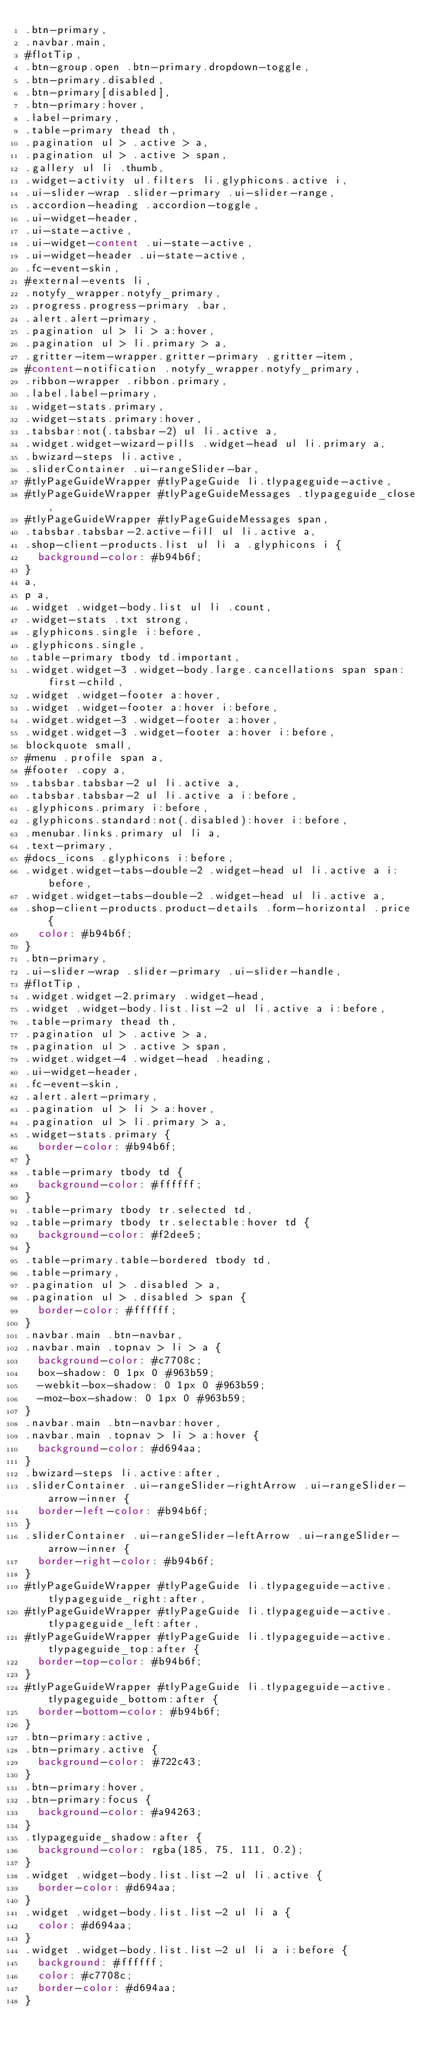<code> <loc_0><loc_0><loc_500><loc_500><_CSS_>.btn-primary,
.navbar.main,
#flotTip,
.btn-group.open .btn-primary.dropdown-toggle,
.btn-primary.disabled,
.btn-primary[disabled],
.btn-primary:hover,
.label-primary,
.table-primary thead th,
.pagination ul > .active > a,
.pagination ul > .active > span,
.gallery ul li .thumb,
.widget-activity ul.filters li.glyphicons.active i,
.ui-slider-wrap .slider-primary .ui-slider-range,
.accordion-heading .accordion-toggle,
.ui-widget-header,
.ui-state-active,
.ui-widget-content .ui-state-active,
.ui-widget-header .ui-state-active,
.fc-event-skin,
#external-events li,
.notyfy_wrapper.notyfy_primary,
.progress.progress-primary .bar,
.alert.alert-primary,
.pagination ul > li > a:hover,
.pagination ul > li.primary > a,
.gritter-item-wrapper.gritter-primary .gritter-item,
#content-notification .notyfy_wrapper.notyfy_primary,
.ribbon-wrapper .ribbon.primary,
.label.label-primary,
.widget-stats.primary,
.widget-stats.primary:hover,
.tabsbar:not(.tabsbar-2) ul li.active a,
.widget.widget-wizard-pills .widget-head ul li.primary a,
.bwizard-steps li.active,
.sliderContainer .ui-rangeSlider-bar,
#tlyPageGuideWrapper #tlyPageGuide li.tlypageguide-active,
#tlyPageGuideWrapper #tlyPageGuideMessages .tlypageguide_close,
#tlyPageGuideWrapper #tlyPageGuideMessages span,
.tabsbar.tabsbar-2.active-fill ul li.active a,
.shop-client-products.list ul li a .glyphicons i {
  background-color: #b94b6f;
}
a,
p a,
.widget .widget-body.list ul li .count,
.widget-stats .txt strong,
.glyphicons.single i:before,
.glyphicons.single,
.table-primary tbody td.important,
.widget.widget-3 .widget-body.large.cancellations span span:first-child,
.widget .widget-footer a:hover,
.widget .widget-footer a:hover i:before,
.widget.widget-3 .widget-footer a:hover,
.widget.widget-3 .widget-footer a:hover i:before,
blockquote small,
#menu .profile span a,
#footer .copy a,
.tabsbar.tabsbar-2 ul li.active a,
.tabsbar.tabsbar-2 ul li.active a i:before,
.glyphicons.primary i:before,
.glyphicons.standard:not(.disabled):hover i:before,
.menubar.links.primary ul li a,
.text-primary,
#docs_icons .glyphicons i:before,
.widget.widget-tabs-double-2 .widget-head ul li.active a i:before,
.widget.widget-tabs-double-2 .widget-head ul li.active a,
.shop-client-products.product-details .form-horizontal .price {
  color: #b94b6f;
}
.btn-primary,
.ui-slider-wrap .slider-primary .ui-slider-handle,
#flotTip,
.widget.widget-2.primary .widget-head,
.widget .widget-body.list.list-2 ul li.active a i:before,
.table-primary thead th,
.pagination ul > .active > a,
.pagination ul > .active > span,
.widget.widget-4 .widget-head .heading,
.ui-widget-header,
.fc-event-skin,
.alert.alert-primary,
.pagination ul > li > a:hover,
.pagination ul > li.primary > a,
.widget-stats.primary {
  border-color: #b94b6f;
}
.table-primary tbody td {
  background-color: #ffffff;
}
.table-primary tbody tr.selected td,
.table-primary tbody tr.selectable:hover td {
  background-color: #f2dee5;
}
.table-primary.table-bordered tbody td,
.table-primary,
.pagination ul > .disabled > a,
.pagination ul > .disabled > span {
  border-color: #ffffff;
}
.navbar.main .btn-navbar,
.navbar.main .topnav > li > a {
  background-color: #c7708c;
  box-shadow: 0 1px 0 #963b59;
  -webkit-box-shadow: 0 1px 0 #963b59;
  -moz-box-shadow: 0 1px 0 #963b59;
}
.navbar.main .btn-navbar:hover,
.navbar.main .topnav > li > a:hover {
  background-color: #d694aa;
}
.bwizard-steps li.active:after,
.sliderContainer .ui-rangeSlider-rightArrow .ui-rangeSlider-arrow-inner {
  border-left-color: #b94b6f;
}
.sliderContainer .ui-rangeSlider-leftArrow .ui-rangeSlider-arrow-inner {
  border-right-color: #b94b6f;
}
#tlyPageGuideWrapper #tlyPageGuide li.tlypageguide-active.tlypageguide_right:after,
#tlyPageGuideWrapper #tlyPageGuide li.tlypageguide-active.tlypageguide_left:after,
#tlyPageGuideWrapper #tlyPageGuide li.tlypageguide-active.tlypageguide_top:after {
  border-top-color: #b94b6f;
}
#tlyPageGuideWrapper #tlyPageGuide li.tlypageguide-active.tlypageguide_bottom:after {
  border-bottom-color: #b94b6f;
}
.btn-primary:active,
.btn-primary.active {
  background-color: #722c43;
}
.btn-primary:hover,
.btn-primary:focus {
  background-color: #a94263;
}
.tlypageguide_shadow:after {
  background-color: rgba(185, 75, 111, 0.2);
}
.widget .widget-body.list.list-2 ul li.active {
  border-color: #d694aa;
}
.widget .widget-body.list.list-2 ul li a {
  color: #d694aa;
}
.widget .widget-body.list.list-2 ul li a i:before {
  background: #ffffff;
  color: #c7708c;
  border-color: #d694aa;
}
</code> 